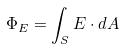<formula> <loc_0><loc_0><loc_500><loc_500>\Phi _ { E } = \int _ { S } E \cdot d A</formula> 